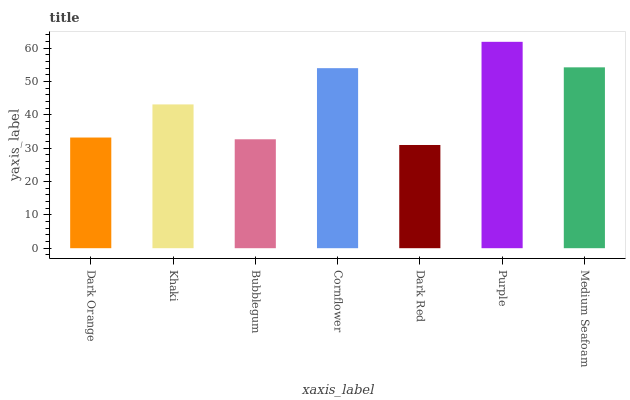Is Dark Red the minimum?
Answer yes or no. Yes. Is Purple the maximum?
Answer yes or no. Yes. Is Khaki the minimum?
Answer yes or no. No. Is Khaki the maximum?
Answer yes or no. No. Is Khaki greater than Dark Orange?
Answer yes or no. Yes. Is Dark Orange less than Khaki?
Answer yes or no. Yes. Is Dark Orange greater than Khaki?
Answer yes or no. No. Is Khaki less than Dark Orange?
Answer yes or no. No. Is Khaki the high median?
Answer yes or no. Yes. Is Khaki the low median?
Answer yes or no. Yes. Is Cornflower the high median?
Answer yes or no. No. Is Purple the low median?
Answer yes or no. No. 